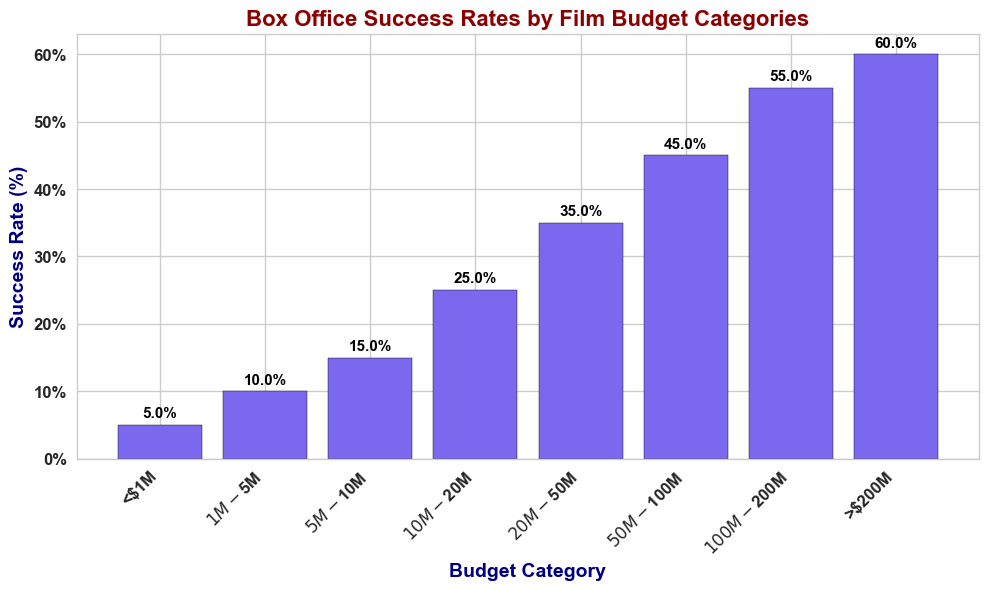What Budget Category has the highest success rate? Examine the bars in the figure to find the tallest bar. The tallest bar corresponds to the `>$200M` Budget Category with a 60% success rate.
Answer: >$200M Which Budget Category has a lower success rate: $10M-$20M or $20M-$50M? Compare the heights of the bars for the $10M-$20M and $20M-$50M categories. The $10M-$20M bar is shorter with a 25% success rate compared to $20M-$50M’s 35%.
Answer: $10M-$20M What is the difference in success rate between the $5M-$10M and $50M-$100M Budget Categories? Note the success rates for $5M-$10M (15%) and $50M-$100M (45%), then calculate the difference: 45% - 15% = 30%.
Answer: 30% How many Budget Categories have success rates of at least 50%? Identify the bars with heights of 50% or more. The $100M-$200M (55%) and >$200M (60%) categories fit this criterion, so there are 2.
Answer: 2 Which Budget Category has the lowest success rate, and what is it? Locate the shortest bar in the plot. The <$1M category is the shortest with a 5% success rate.
Answer: <$1M, 5% Rank the Budget Categories in terms of their success rates from highest to lowest. Rearrange the categories based on the heights of their bars: >$200M (60%), $100M-$200M (55%), $50M-$100M (45%), $20M-$50M (35%), $10M-$20M (25%), $5M-$10M (15%), $1M-$5M (10%), <$1M (5%).
Answer: >$200M, $100M-$200M, $50M-$100M, $20M-$50M, $10M-$20M, $5M-$10M, $1M-$5M, <$1M Calculate the average success rate for Budget Categories that have success rates below 25%. Identify categories below 25%: <$1M (5%), $1M-$5M (10%), $5M-$10M (15%). Average: (5% + 10% + 15%) / 3 = 10%.
Answer: 10% What is the combined success rate of the <$1M and $100M-$200M Budget Categories? Sum the success rates: <$1M (5%) + $100M-$200M (55%) = 60%.
Answer: 60% Does any Budget Category have exactly a 15% success rate? Check each bar for a 15% success rate. The $5M-$10M category fits this criterion.
Answer: Yes, $5M-$10M Analyze the change in success rate from the $50M-$100M to the >$200M Budget Category. Note the success rates: $50M-$100M (45%), >$200M (60%). Calculate the change: 60% - 45% = 15% increase.
Answer: 15% increase 